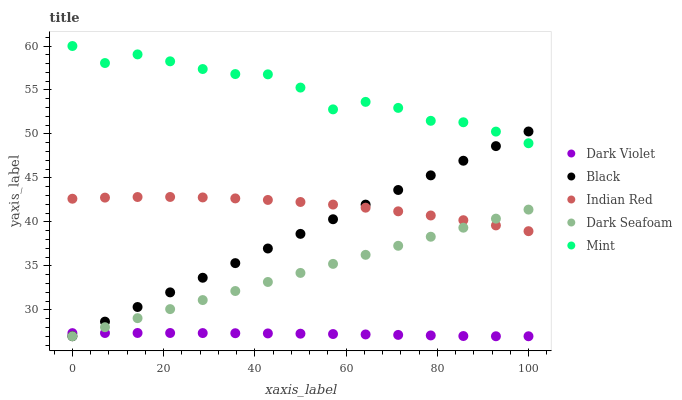Does Dark Violet have the minimum area under the curve?
Answer yes or no. Yes. Does Mint have the maximum area under the curve?
Answer yes or no. Yes. Does Dark Seafoam have the minimum area under the curve?
Answer yes or no. No. Does Dark Seafoam have the maximum area under the curve?
Answer yes or no. No. Is Dark Seafoam the smoothest?
Answer yes or no. Yes. Is Mint the roughest?
Answer yes or no. Yes. Is Black the smoothest?
Answer yes or no. No. Is Black the roughest?
Answer yes or no. No. Does Dark Seafoam have the lowest value?
Answer yes or no. Yes. Does Indian Red have the lowest value?
Answer yes or no. No. Does Mint have the highest value?
Answer yes or no. Yes. Does Dark Seafoam have the highest value?
Answer yes or no. No. Is Dark Violet less than Mint?
Answer yes or no. Yes. Is Indian Red greater than Dark Violet?
Answer yes or no. Yes. Does Black intersect Dark Violet?
Answer yes or no. Yes. Is Black less than Dark Violet?
Answer yes or no. No. Is Black greater than Dark Violet?
Answer yes or no. No. Does Dark Violet intersect Mint?
Answer yes or no. No. 